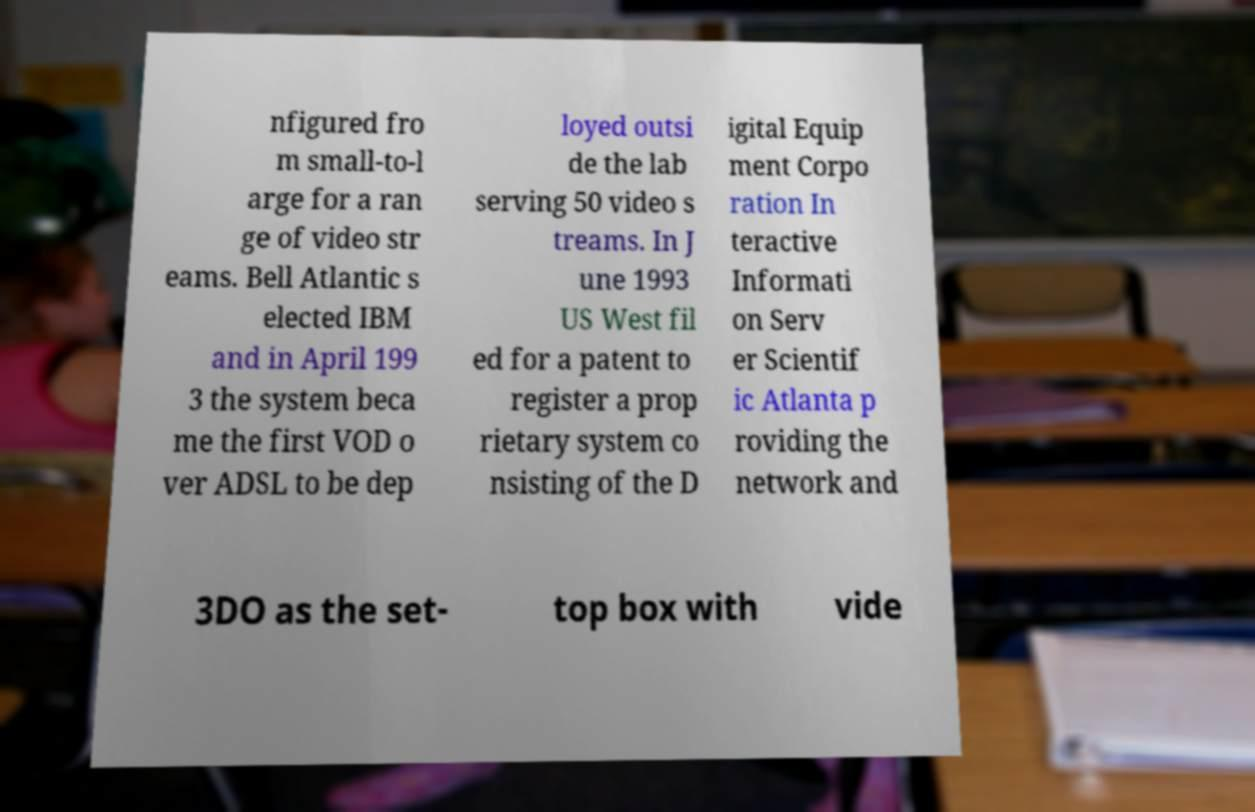For documentation purposes, I need the text within this image transcribed. Could you provide that? nfigured fro m small-to-l arge for a ran ge of video str eams. Bell Atlantic s elected IBM and in April 199 3 the system beca me the first VOD o ver ADSL to be dep loyed outsi de the lab serving 50 video s treams. In J une 1993 US West fil ed for a patent to register a prop rietary system co nsisting of the D igital Equip ment Corpo ration In teractive Informati on Serv er Scientif ic Atlanta p roviding the network and 3DO as the set- top box with vide 